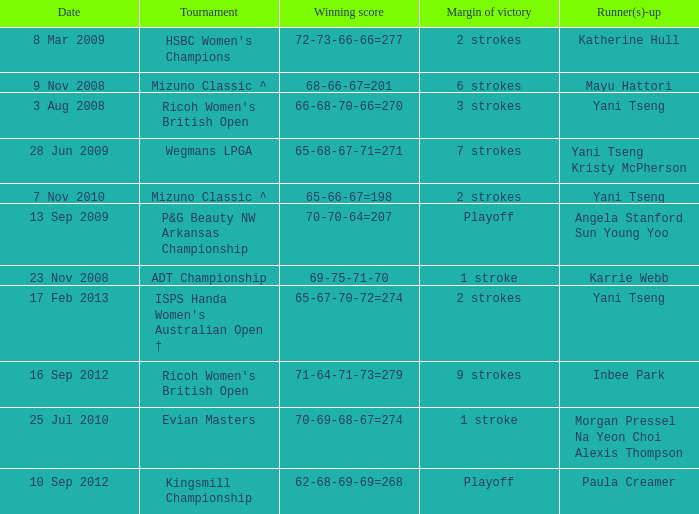What tournament had a victory of a 1 stroke margin and the final winning score 69-75-71-70? ADT Championship. 